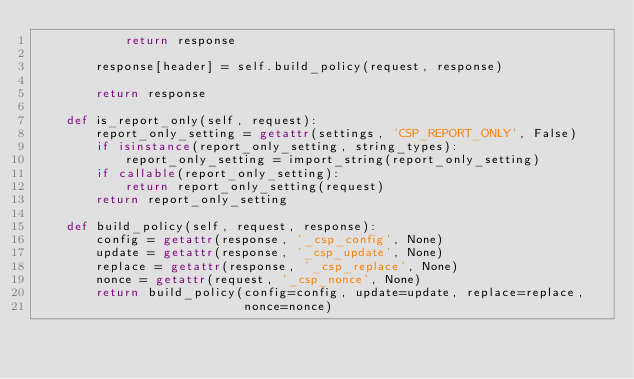Convert code to text. <code><loc_0><loc_0><loc_500><loc_500><_Python_>            return response

        response[header] = self.build_policy(request, response)

        return response

    def is_report_only(self, request):
        report_only_setting = getattr(settings, 'CSP_REPORT_ONLY', False)
        if isinstance(report_only_setting, string_types):
            report_only_setting = import_string(report_only_setting)
        if callable(report_only_setting):
            return report_only_setting(request)
        return report_only_setting

    def build_policy(self, request, response):
        config = getattr(response, '_csp_config', None)
        update = getattr(response, '_csp_update', None)
        replace = getattr(response, '_csp_replace', None)
        nonce = getattr(request, '_csp_nonce', None)
        return build_policy(config=config, update=update, replace=replace,
                            nonce=nonce)
</code> 